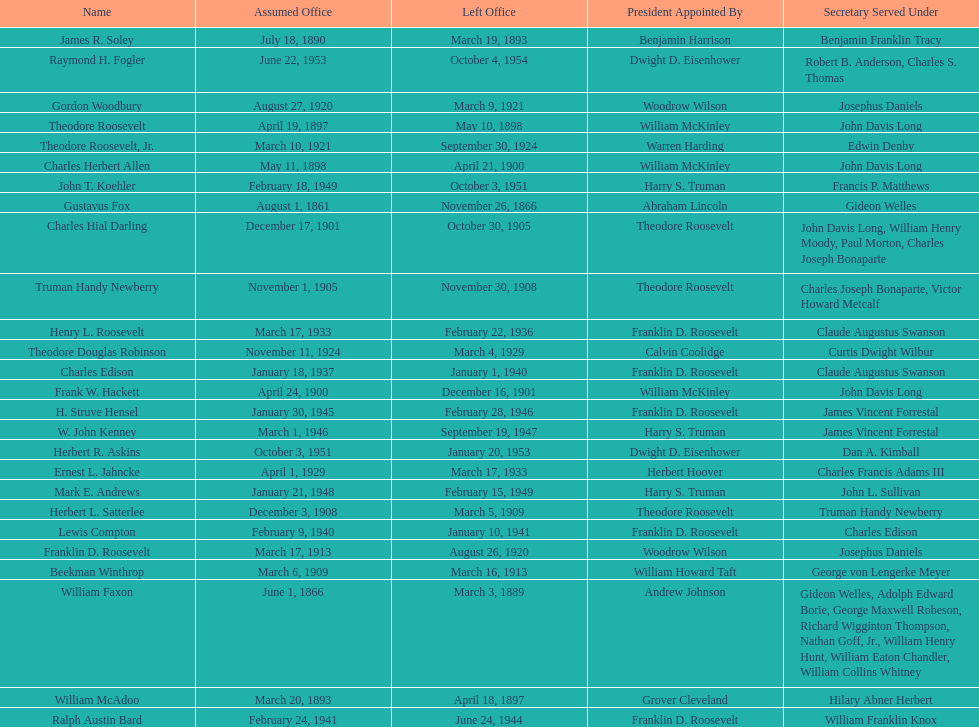Who was the first assistant secretary of the navy? Gustavus Fox. 